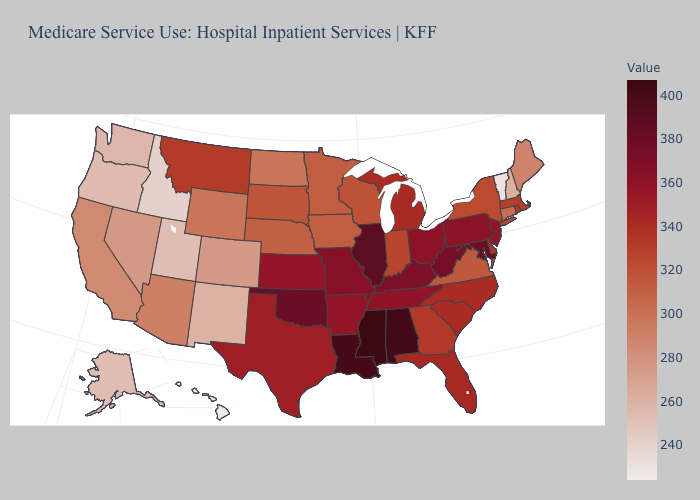Which states have the highest value in the USA?
Give a very brief answer. Mississippi. Among the states that border Indiana , does Kentucky have the highest value?
Give a very brief answer. No. Does Hawaii have the lowest value in the USA?
Quick response, please. Yes. Among the states that border Kentucky , which have the highest value?
Give a very brief answer. Illinois. 